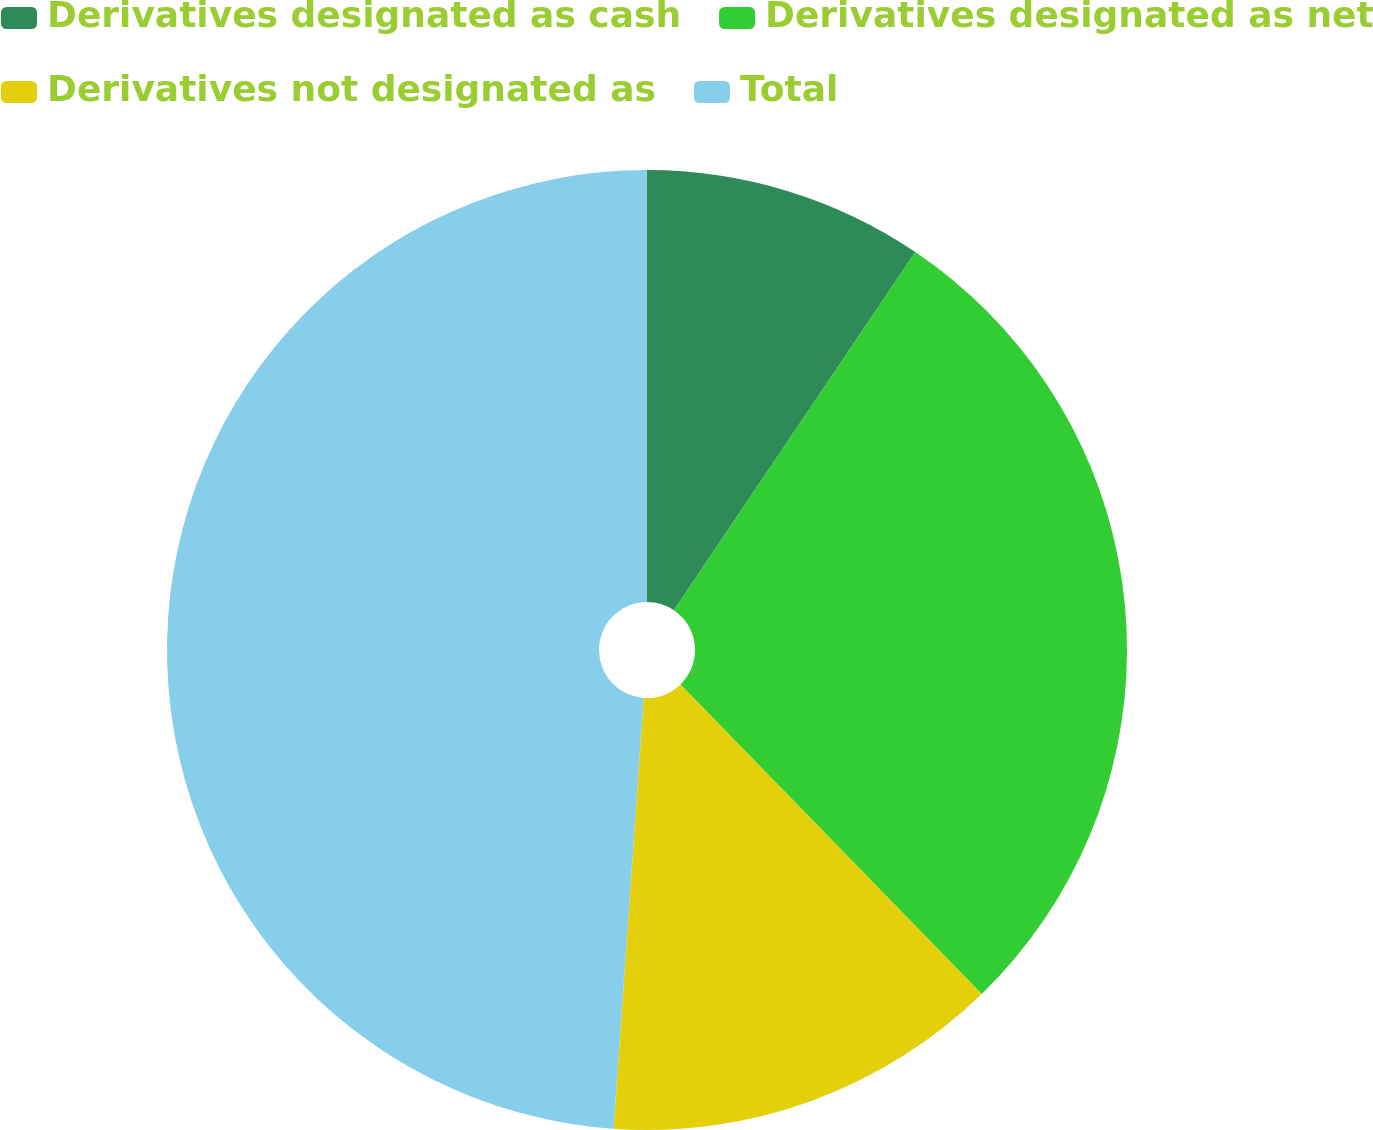Convert chart. <chart><loc_0><loc_0><loc_500><loc_500><pie_chart><fcel>Derivatives designated as cash<fcel>Derivatives designated as net<fcel>Derivatives not designated as<fcel>Total<nl><fcel>9.44%<fcel>28.28%<fcel>13.39%<fcel>48.89%<nl></chart> 